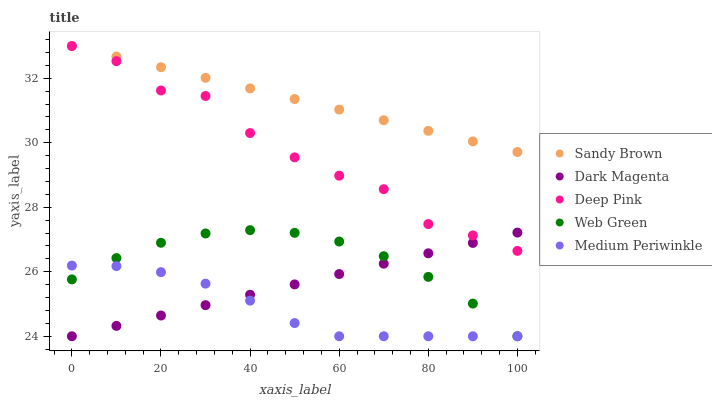Does Medium Periwinkle have the minimum area under the curve?
Answer yes or no. Yes. Does Sandy Brown have the maximum area under the curve?
Answer yes or no. Yes. Does Deep Pink have the minimum area under the curve?
Answer yes or no. No. Does Deep Pink have the maximum area under the curve?
Answer yes or no. No. Is Dark Magenta the smoothest?
Answer yes or no. Yes. Is Deep Pink the roughest?
Answer yes or no. Yes. Is Sandy Brown the smoothest?
Answer yes or no. No. Is Sandy Brown the roughest?
Answer yes or no. No. Does Medium Periwinkle have the lowest value?
Answer yes or no. Yes. Does Deep Pink have the lowest value?
Answer yes or no. No. Does Sandy Brown have the highest value?
Answer yes or no. Yes. Does Dark Magenta have the highest value?
Answer yes or no. No. Is Medium Periwinkle less than Deep Pink?
Answer yes or no. Yes. Is Sandy Brown greater than Web Green?
Answer yes or no. Yes. Does Deep Pink intersect Dark Magenta?
Answer yes or no. Yes. Is Deep Pink less than Dark Magenta?
Answer yes or no. No. Is Deep Pink greater than Dark Magenta?
Answer yes or no. No. Does Medium Periwinkle intersect Deep Pink?
Answer yes or no. No. 